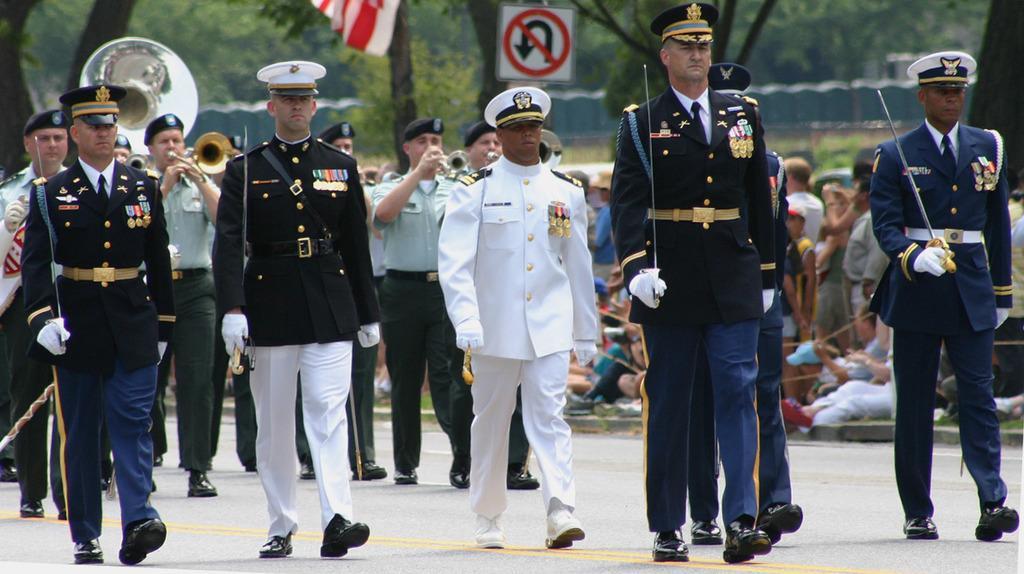Please provide a concise description of this image. In the picture we can see some army people doing a parade on the road holding a swords and wearing a cape, behind them also we can see some people with uniform playing a musical instruments and in the background we can see some people sitting on the path and some are standing and behind them we can see trees and a wall. 